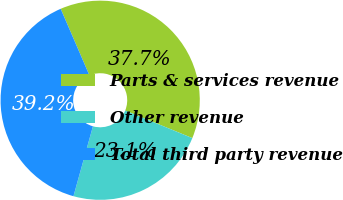<chart> <loc_0><loc_0><loc_500><loc_500><pie_chart><fcel>Parts & services revenue<fcel>Other revenue<fcel>Total third party revenue<nl><fcel>37.7%<fcel>23.12%<fcel>39.19%<nl></chart> 